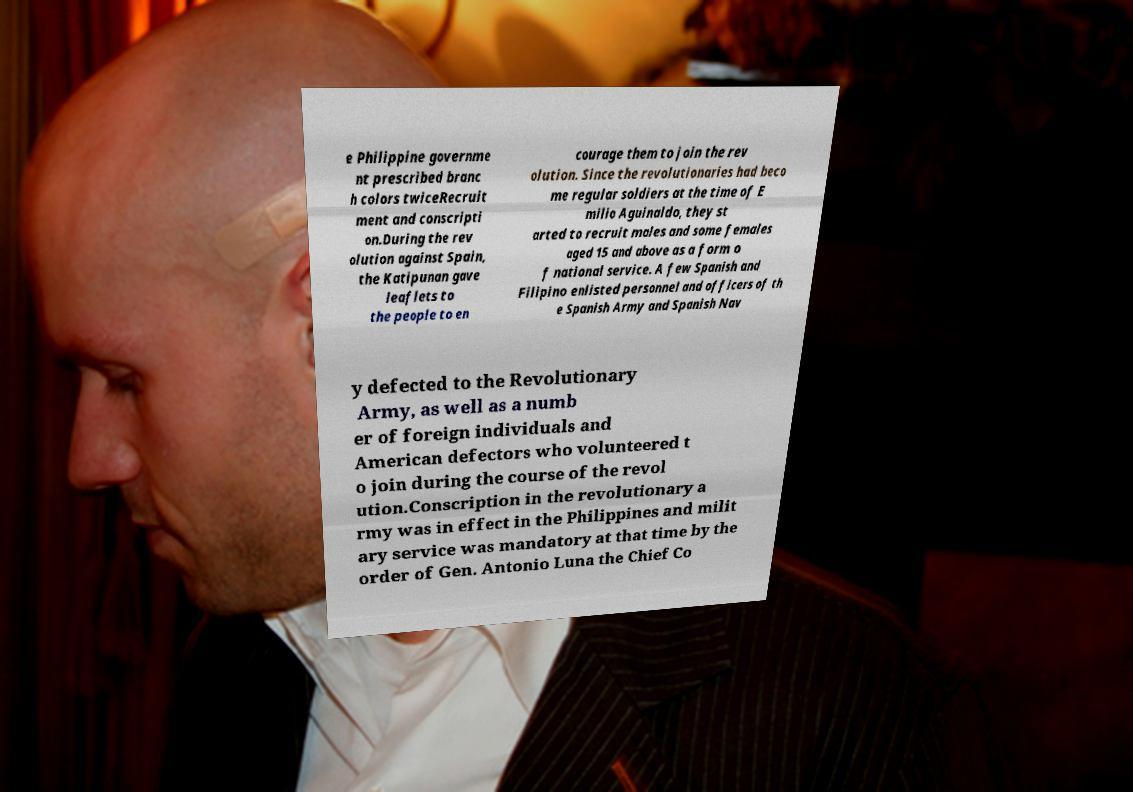Could you extract and type out the text from this image? e Philippine governme nt prescribed branc h colors twiceRecruit ment and conscripti on.During the rev olution against Spain, the Katipunan gave leaflets to the people to en courage them to join the rev olution. Since the revolutionaries had beco me regular soldiers at the time of E milio Aguinaldo, they st arted to recruit males and some females aged 15 and above as a form o f national service. A few Spanish and Filipino enlisted personnel and officers of th e Spanish Army and Spanish Nav y defected to the Revolutionary Army, as well as a numb er of foreign individuals and American defectors who volunteered t o join during the course of the revol ution.Conscription in the revolutionary a rmy was in effect in the Philippines and milit ary service was mandatory at that time by the order of Gen. Antonio Luna the Chief Co 